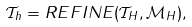Convert formula to latex. <formula><loc_0><loc_0><loc_500><loc_500>\mathcal { T } _ { h } = R E F I N E ( \mathcal { T } _ { H } , \mathcal { M } _ { H } ) ,</formula> 